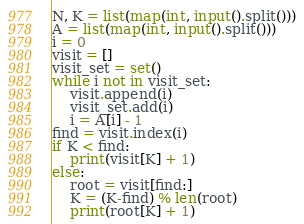Convert code to text. <code><loc_0><loc_0><loc_500><loc_500><_Python_>N, K = list(map(int, input().split()))
A = list(map(int, input().split()))
i = 0
visit = []
visit_set = set()
while i not in visit_set:
    visit.append(i)
    visit_set.add(i)
    i = A[i] - 1
find = visit.index(i)
if K < find:
    print(visit[K] + 1)
else:
    root = visit[find:]
    K = (K-find) % len(root)
    print(root[K] + 1)</code> 